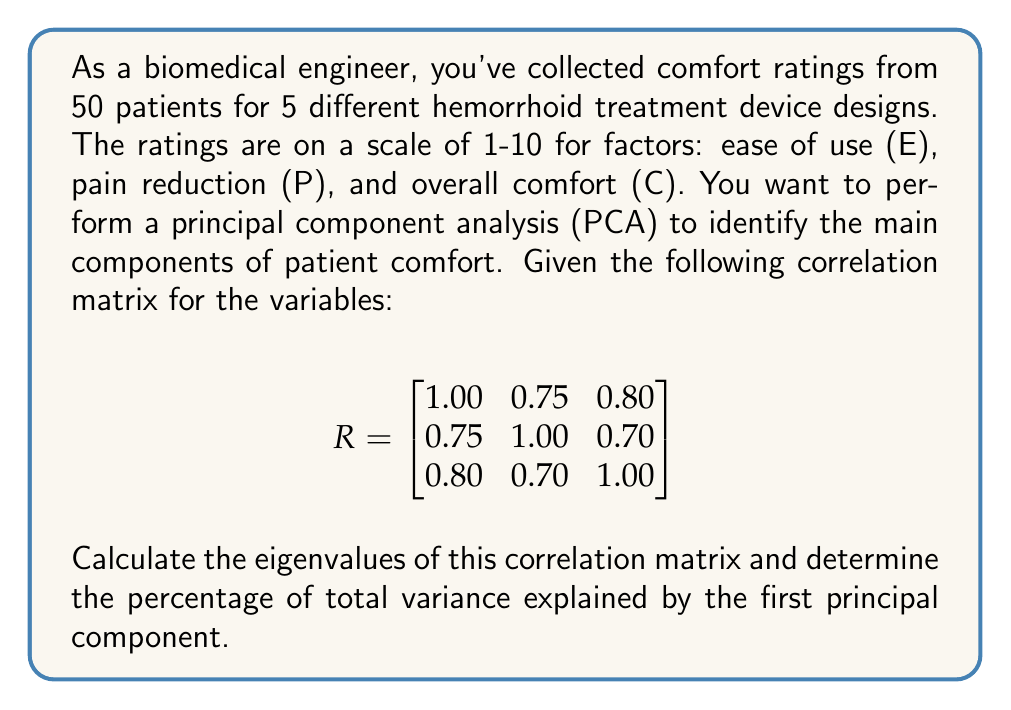Can you answer this question? To solve this problem, we'll follow these steps:

1) First, we need to find the eigenvalues of the correlation matrix R. The characteristic equation is:

   $$det(R - \lambda I) = 0$$

2) Expanding this determinant:

   $$\begin{vmatrix}
   1-\lambda & 0.75 & 0.80 \\
   0.75 & 1-\lambda & 0.70 \\
   0.80 & 0.70 & 1-\lambda
   \end{vmatrix} = 0$$

3) This expands to the cubic equation:

   $$-\lambda^3 + 3\lambda^2 - 0.7125\lambda - 0.5375 = 0$$

4) Solving this equation (using a calculator or computer algebra system) gives us the eigenvalues:

   $$\lambda_1 \approx 2.4861, \lambda_2 \approx 0.3723, \lambda_3 \approx 0.1416$$

5) In PCA, the eigenvalues represent the variance explained by each principal component. The total variance is the sum of the eigenvalues:

   $$Total Variance = 2.4861 + 0.3723 + 0.1416 = 3$$

   Note: The total variance is always equal to the number of variables in a correlation matrix.

6) The percentage of variance explained by the first principal component is:

   $$\frac{\lambda_1}{Total Variance} \times 100\% = \frac{2.4861}{3} \times 100\% \approx 82.87\%$$

Therefore, the first principal component explains approximately 82.87% of the total variance in patient comfort ratings.
Answer: 82.87% 